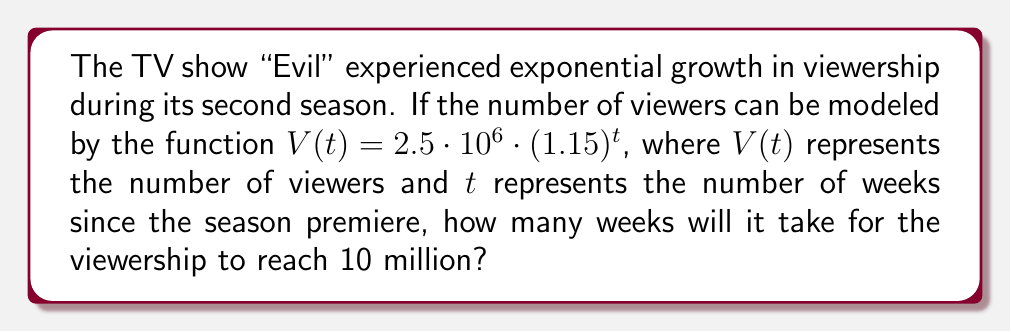Solve this math problem. Let's approach this step-by-step:

1) We need to find $t$ when $V(t) = 10 \cdot 10^6$ (10 million viewers).

2) Set up the equation:
   $10 \cdot 10^6 = 2.5 \cdot 10^6 \cdot (1.15)^t$

3) Simplify the left side:
   $10 = 2.5 \cdot (1.15)^t$

4) Divide both sides by 2.5:
   $4 = (1.15)^t$

5) Take the natural log of both sides:
   $\ln(4) = \ln((1.15)^t)$

6) Use the logarithm property $\ln(a^b) = b\ln(a)$:
   $\ln(4) = t \cdot \ln(1.15)$

7) Solve for $t$:
   $t = \frac{\ln(4)}{\ln(1.15)}$

8) Use a calculator to evaluate:
   $t \approx 9.6115$

9) Since we can only have whole numbers of weeks, we need to round up to the next integer.
Answer: 10 weeks 